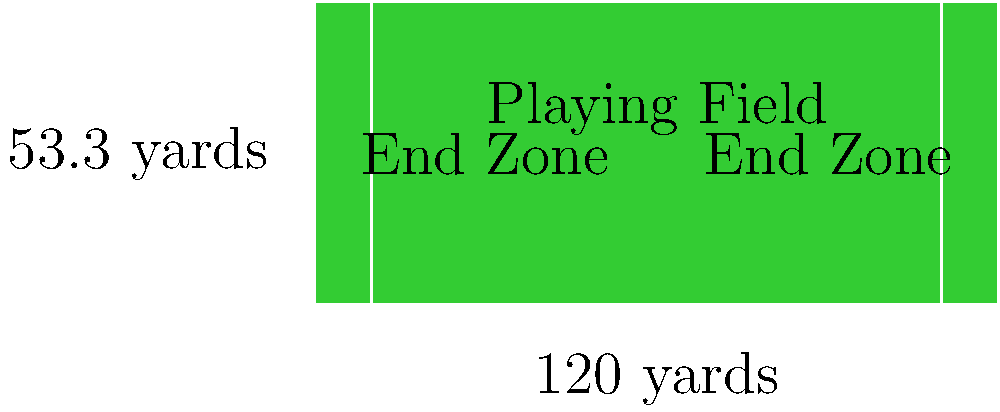As a savvy football fan, you know that field dimensions are crucial. A standard NFL football field is 120 yards long and 53.3 yards wide, including two 10-yard end zones. Calculate the total area of the football field in square feet, rounding your answer to the nearest whole number. (Hint: 1 yard = 3 feet) Let's break this down step-by-step:

1) First, we need to convert the dimensions from yards to feet:
   Length: $120 \text{ yards} \times 3 \text{ feet/yard} = 360 \text{ feet}$
   Width: $53.3 \text{ yards} \times 3 \text{ feet/yard} = 159.9 \text{ feet}$

2) Now we can calculate the area using the formula for a rectangle:
   $\text{Area} = \text{Length} \times \text{Width}$

3) Plugging in our values:
   $\text{Area} = 360 \text{ feet} \times 159.9 \text{ feet} = 57,564 \text{ square feet}$

4) The question asks for the answer rounded to the nearest whole number, but our result is already a whole number.

Therefore, the total area of the football field is 57,564 square feet.
Answer: 57,564 sq ft 